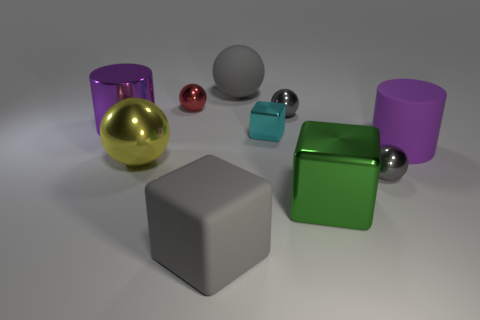How many gray balls must be subtracted to get 2 gray balls? 1 Subtract all matte balls. How many balls are left? 4 Subtract all brown cylinders. How many gray spheres are left? 3 Subtract all gray cubes. How many cubes are left? 2 Subtract 1 blocks. How many blocks are left? 2 Add 7 brown shiny balls. How many brown shiny balls exist? 7 Subtract 1 gray blocks. How many objects are left? 9 Subtract all cylinders. How many objects are left? 8 Subtract all gray cubes. Subtract all cyan spheres. How many cubes are left? 2 Subtract all tiny red shiny things. Subtract all big gray rubber things. How many objects are left? 7 